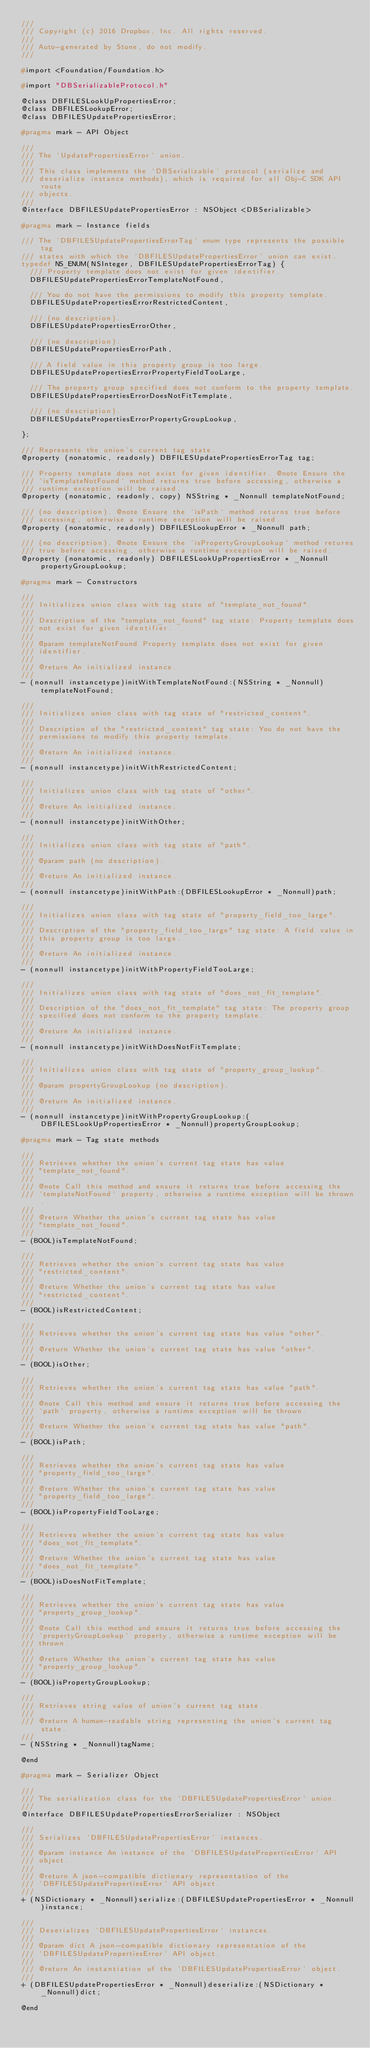<code> <loc_0><loc_0><loc_500><loc_500><_C_>///
/// Copyright (c) 2016 Dropbox, Inc. All rights reserved.
///
/// Auto-generated by Stone, do not modify.
///

#import <Foundation/Foundation.h>

#import "DBSerializableProtocol.h"

@class DBFILESLookUpPropertiesError;
@class DBFILESLookupError;
@class DBFILESUpdatePropertiesError;

#pragma mark - API Object

///
/// The `UpdatePropertiesError` union.
///
/// This class implements the `DBSerializable` protocol (serialize and
/// deserialize instance methods), which is required for all Obj-C SDK API route
/// objects.
///
@interface DBFILESUpdatePropertiesError : NSObject <DBSerializable>

#pragma mark - Instance fields

/// The `DBFILESUpdatePropertiesErrorTag` enum type represents the possible tag
/// states with which the `DBFILESUpdatePropertiesError` union can exist.
typedef NS_ENUM(NSInteger, DBFILESUpdatePropertiesErrorTag) {
  /// Property template does not exist for given identifier.
  DBFILESUpdatePropertiesErrorTemplateNotFound,

  /// You do not have the permissions to modify this property template.
  DBFILESUpdatePropertiesErrorRestrictedContent,

  /// (no description).
  DBFILESUpdatePropertiesErrorOther,

  /// (no description).
  DBFILESUpdatePropertiesErrorPath,

  /// A field value in this property group is too large.
  DBFILESUpdatePropertiesErrorPropertyFieldTooLarge,

  /// The property group specified does not conform to the property template.
  DBFILESUpdatePropertiesErrorDoesNotFitTemplate,

  /// (no description).
  DBFILESUpdatePropertiesErrorPropertyGroupLookup,

};

/// Represents the union's current tag state.
@property (nonatomic, readonly) DBFILESUpdatePropertiesErrorTag tag;

/// Property template does not exist for given identifier. @note Ensure the
/// `isTemplateNotFound` method returns true before accessing, otherwise a
/// runtime exception will be raised.
@property (nonatomic, readonly, copy) NSString * _Nonnull templateNotFound;

/// (no description). @note Ensure the `isPath` method returns true before
/// accessing, otherwise a runtime exception will be raised.
@property (nonatomic, readonly) DBFILESLookupError * _Nonnull path;

/// (no description). @note Ensure the `isPropertyGroupLookup` method returns
/// true before accessing, otherwise a runtime exception will be raised.
@property (nonatomic, readonly) DBFILESLookUpPropertiesError * _Nonnull propertyGroupLookup;

#pragma mark - Constructors

///
/// Initializes union class with tag state of "template_not_found".
///
/// Description of the "template_not_found" tag state: Property template does
/// not exist for given identifier.
///
/// @param templateNotFound Property template does not exist for given
/// identifier.
///
/// @return An initialized instance.
///
- (nonnull instancetype)initWithTemplateNotFound:(NSString * _Nonnull)templateNotFound;

///
/// Initializes union class with tag state of "restricted_content".
///
/// Description of the "restricted_content" tag state: You do not have the
/// permissions to modify this property template.
///
/// @return An initialized instance.
///
- (nonnull instancetype)initWithRestrictedContent;

///
/// Initializes union class with tag state of "other".
///
/// @return An initialized instance.
///
- (nonnull instancetype)initWithOther;

///
/// Initializes union class with tag state of "path".
///
/// @param path (no description).
///
/// @return An initialized instance.
///
- (nonnull instancetype)initWithPath:(DBFILESLookupError * _Nonnull)path;

///
/// Initializes union class with tag state of "property_field_too_large".
///
/// Description of the "property_field_too_large" tag state: A field value in
/// this property group is too large.
///
/// @return An initialized instance.
///
- (nonnull instancetype)initWithPropertyFieldTooLarge;

///
/// Initializes union class with tag state of "does_not_fit_template".
///
/// Description of the "does_not_fit_template" tag state: The property group
/// specified does not conform to the property template.
///
/// @return An initialized instance.
///
- (nonnull instancetype)initWithDoesNotFitTemplate;

///
/// Initializes union class with tag state of "property_group_lookup".
///
/// @param propertyGroupLookup (no description).
///
/// @return An initialized instance.
///
- (nonnull instancetype)initWithPropertyGroupLookup:(DBFILESLookUpPropertiesError * _Nonnull)propertyGroupLookup;

#pragma mark - Tag state methods

///
/// Retrieves whether the union's current tag state has value
/// "template_not_found".
///
/// @note Call this method and ensure it returns true before accessing the
/// `templateNotFound` property, otherwise a runtime exception will be thrown.
///
/// @return Whether the union's current tag state has value
/// "template_not_found".
///
- (BOOL)isTemplateNotFound;

///
/// Retrieves whether the union's current tag state has value
/// "restricted_content".
///
/// @return Whether the union's current tag state has value
/// "restricted_content".
///
- (BOOL)isRestrictedContent;

///
/// Retrieves whether the union's current tag state has value "other".
///
/// @return Whether the union's current tag state has value "other".
///
- (BOOL)isOther;

///
/// Retrieves whether the union's current tag state has value "path".
///
/// @note Call this method and ensure it returns true before accessing the
/// `path` property, otherwise a runtime exception will be thrown.
///
/// @return Whether the union's current tag state has value "path".
///
- (BOOL)isPath;

///
/// Retrieves whether the union's current tag state has value
/// "property_field_too_large".
///
/// @return Whether the union's current tag state has value
/// "property_field_too_large".
///
- (BOOL)isPropertyFieldTooLarge;

///
/// Retrieves whether the union's current tag state has value
/// "does_not_fit_template".
///
/// @return Whether the union's current tag state has value
/// "does_not_fit_template".
///
- (BOOL)isDoesNotFitTemplate;

///
/// Retrieves whether the union's current tag state has value
/// "property_group_lookup".
///
/// @note Call this method and ensure it returns true before accessing the
/// `propertyGroupLookup` property, otherwise a runtime exception will be
/// thrown.
///
/// @return Whether the union's current tag state has value
/// "property_group_lookup".
///
- (BOOL)isPropertyGroupLookup;

///
/// Retrieves string value of union's current tag state.
///
/// @return A human-readable string representing the union's current tag state.
///
- (NSString * _Nonnull)tagName;

@end

#pragma mark - Serializer Object

///
/// The serialization class for the `DBFILESUpdatePropertiesError` union.
///
@interface DBFILESUpdatePropertiesErrorSerializer : NSObject

///
/// Serializes `DBFILESUpdatePropertiesError` instances.
///
/// @param instance An instance of the `DBFILESUpdatePropertiesError` API
/// object.
///
/// @return A json-compatible dictionary representation of the
/// `DBFILESUpdatePropertiesError` API object.
///
+ (NSDictionary * _Nonnull)serialize:(DBFILESUpdatePropertiesError * _Nonnull)instance;

///
/// Deserializes `DBFILESUpdatePropertiesError` instances.
///
/// @param dict A json-compatible dictionary representation of the
/// `DBFILESUpdatePropertiesError` API object.
///
/// @return An instantiation of the `DBFILESUpdatePropertiesError` object.
///
+ (DBFILESUpdatePropertiesError * _Nonnull)deserialize:(NSDictionary * _Nonnull)dict;

@end
</code> 